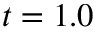Convert formula to latex. <formula><loc_0><loc_0><loc_500><loc_500>t = 1 . 0</formula> 